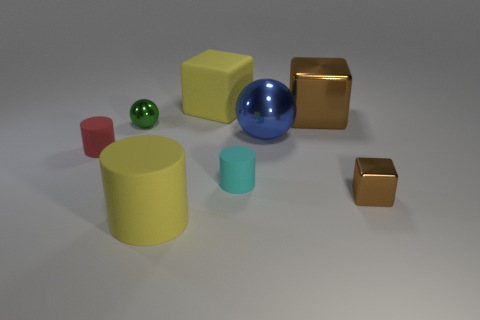Add 1 gray matte cubes. How many objects exist? 9 Subtract all balls. How many objects are left? 6 Add 8 tiny shiny cubes. How many tiny shiny cubes are left? 9 Add 5 small purple rubber things. How many small purple rubber things exist? 5 Subtract 0 cyan cubes. How many objects are left? 8 Subtract all small green metallic things. Subtract all small cyan rubber objects. How many objects are left? 6 